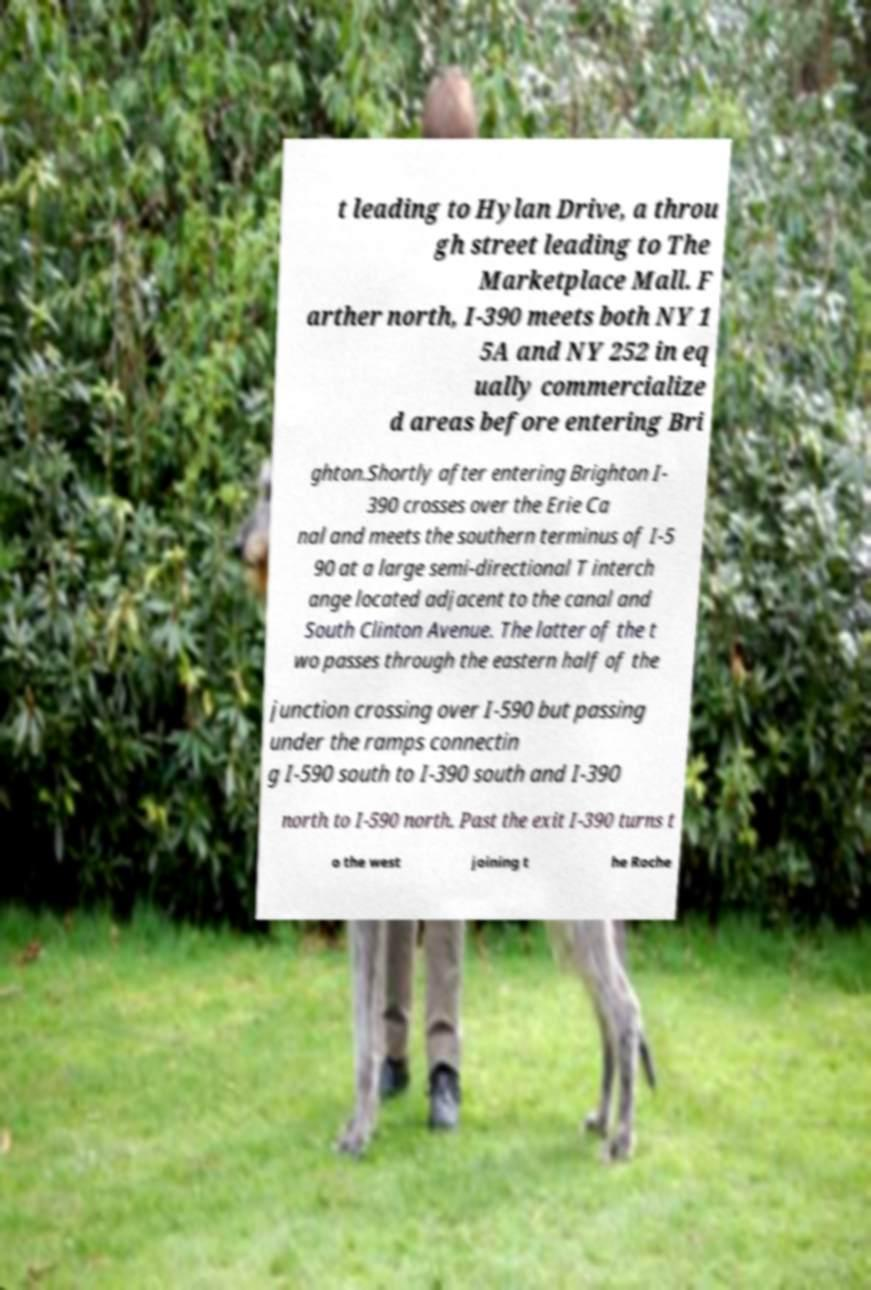Can you accurately transcribe the text from the provided image for me? t leading to Hylan Drive, a throu gh street leading to The Marketplace Mall. F arther north, I-390 meets both NY 1 5A and NY 252 in eq ually commercialize d areas before entering Bri ghton.Shortly after entering Brighton I- 390 crosses over the Erie Ca nal and meets the southern terminus of I-5 90 at a large semi-directional T interch ange located adjacent to the canal and South Clinton Avenue. The latter of the t wo passes through the eastern half of the junction crossing over I-590 but passing under the ramps connectin g I-590 south to I-390 south and I-390 north to I-590 north. Past the exit I-390 turns t o the west joining t he Roche 